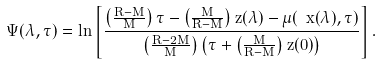Convert formula to latex. <formula><loc_0><loc_0><loc_500><loc_500>\Psi ( \lambda , \tau ) = \ln \left [ \frac { \left ( \frac { R - M } { M } \right ) \tau - \left ( \frac { M } { R - M } \right ) z ( \lambda ) - \mu ( \ x ( \lambda ) , \tau ) } { \left ( \frac { R - 2 M } { M } \right ) \left ( \tau + \left ( \frac { M } { R - M } \right ) z ( 0 ) \right ) } \right ] .</formula> 